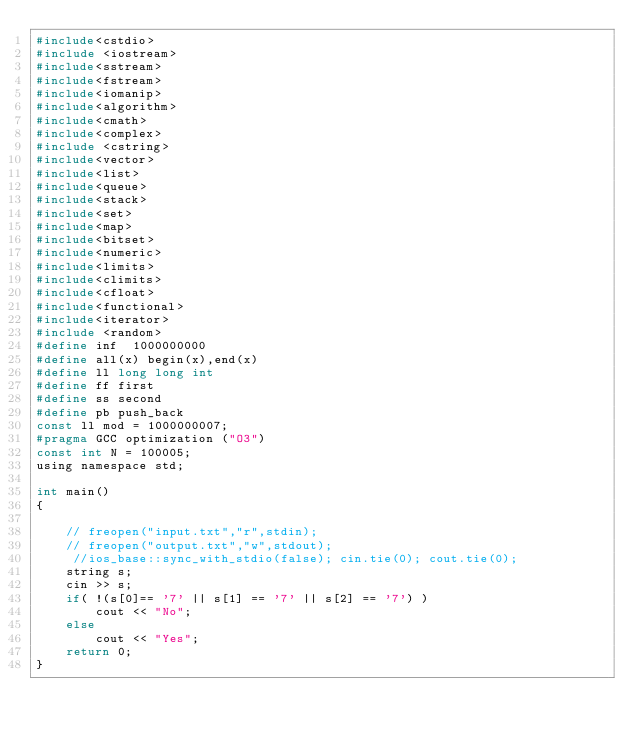<code> <loc_0><loc_0><loc_500><loc_500><_C_>#include<cstdio>
#include <iostream>
#include<sstream>
#include<fstream>
#include<iomanip>
#include<algorithm>
#include<cmath>
#include<complex>
#include <cstring>
#include<vector>
#include<list>
#include<queue>
#include<stack>
#include<set>
#include<map>
#include<bitset>
#include<numeric>
#include<limits>
#include<climits>
#include<cfloat>
#include<functional>
#include<iterator>
#include <random>
#define inf  1000000000
#define all(x) begin(x),end(x)
#define ll long long int
#define ff first
#define ss second
#define pb push_back
const ll mod = 1000000007;
#pragma GCC optimization ("O3")
const int N = 100005;
using namespace std;

int main()
{
 
    // freopen("input.txt","r",stdin);
    // freopen("output.txt","w",stdout);
     //ios_base::sync_with_stdio(false); cin.tie(0); cout.tie(0);
    string s;
    cin >> s;
    if( !(s[0]== '7' || s[1] == '7' || s[2] == '7') )
        cout << "No";
    else
        cout << "Yes"; 
    return 0;
} </code> 